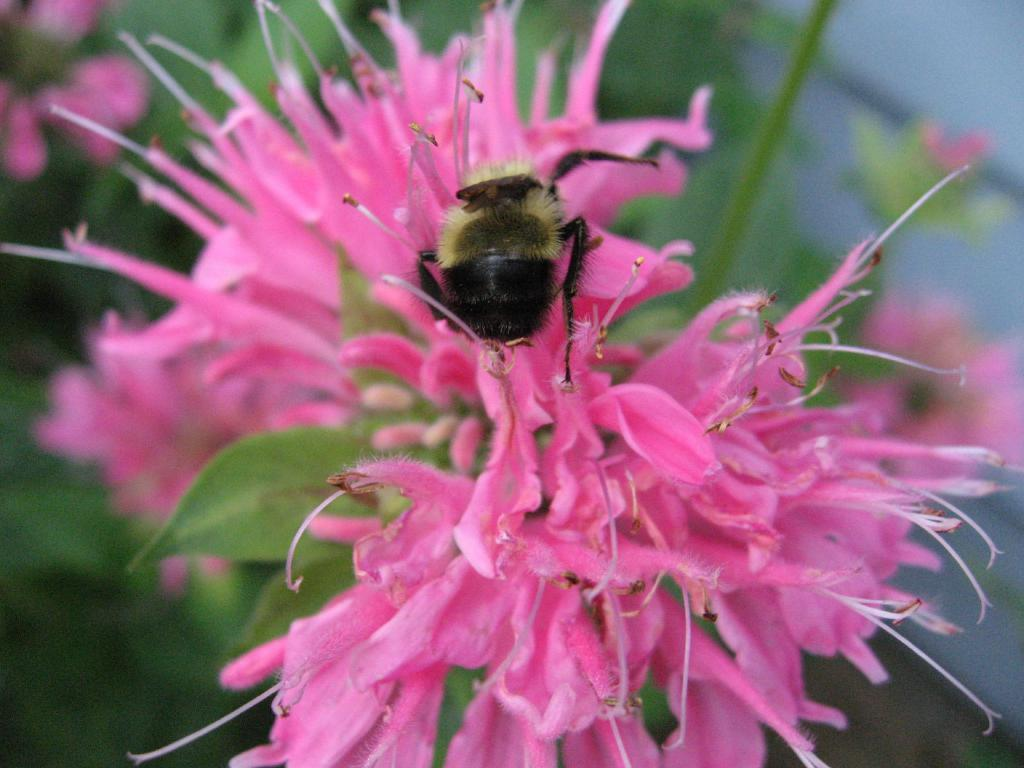What type of flower can be seen in the image? There is a pink color flower in the image. Is there anything on the flower? Yes, there is an insect on the flower. Can you describe the insect? The insect is black and cream in color. Where is the playground located in the image? There is no playground present in the image. What type of brick is used to build the flower in the image? The flower is a natural object and not made of bricks. 